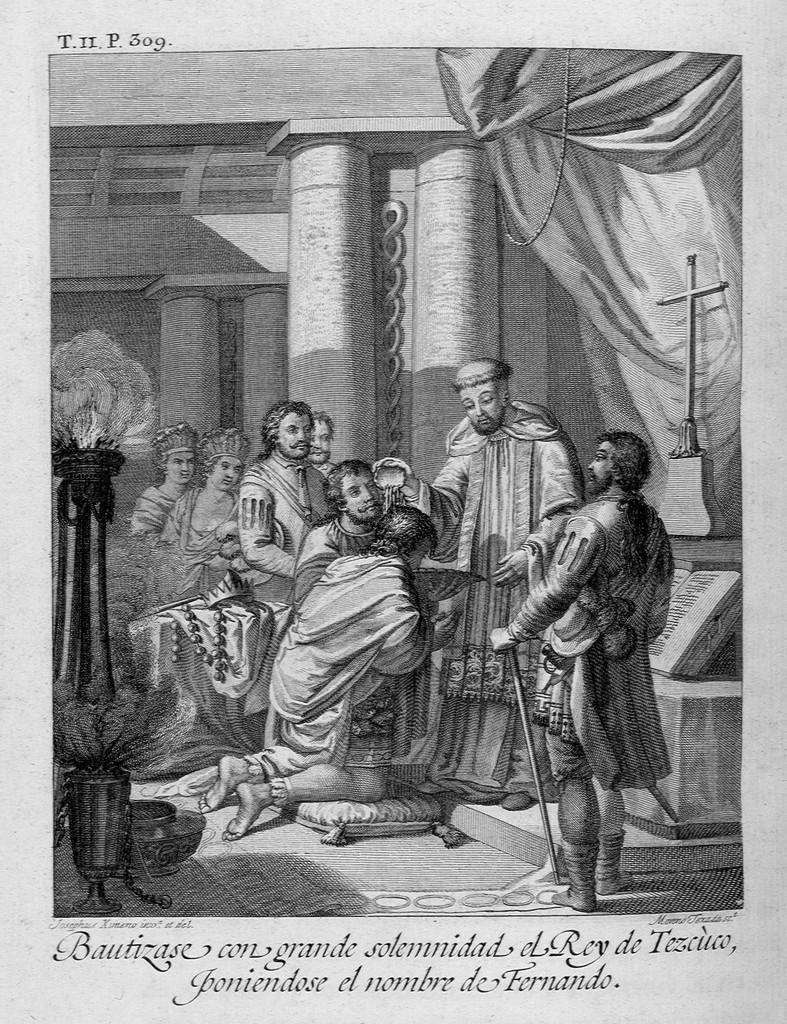What is the color scheme of the painting in the image? The image is a black and white painting. How many people are depicted in the painting? There are many people in the painting. What other objects can be seen in the painting besides people? There are flower pots and pillars in the painting. What is written at the bottom of the painting? There is text at the bottom of the painting. What type of offer is being made by the frogs in the painting? There are no frogs present in the painting; it features people, flower pots, and pillars. 